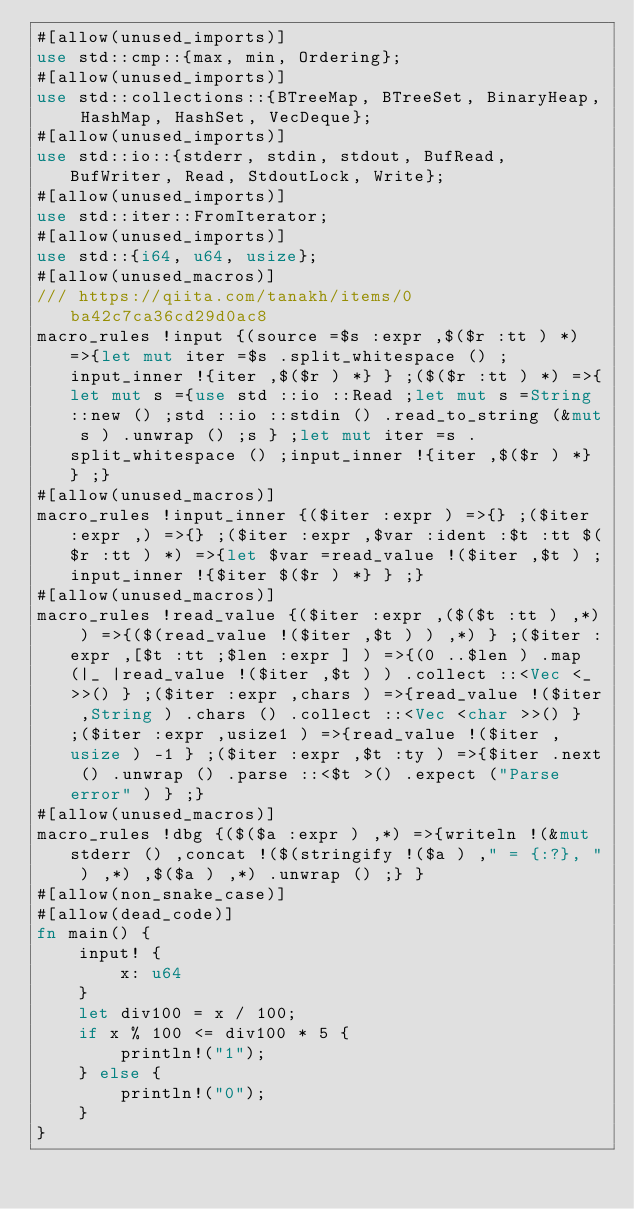Convert code to text. <code><loc_0><loc_0><loc_500><loc_500><_Rust_>#[allow(unused_imports)]
use std::cmp::{max, min, Ordering};
#[allow(unused_imports)]
use std::collections::{BTreeMap, BTreeSet, BinaryHeap, HashMap, HashSet, VecDeque};
#[allow(unused_imports)]
use std::io::{stderr, stdin, stdout, BufRead, BufWriter, Read, StdoutLock, Write};
#[allow(unused_imports)]
use std::iter::FromIterator;
#[allow(unused_imports)]
use std::{i64, u64, usize};
#[allow(unused_macros)]
/// https://qiita.com/tanakh/items/0ba42c7ca36cd29d0ac8
macro_rules !input {(source =$s :expr ,$($r :tt ) *) =>{let mut iter =$s .split_whitespace () ;input_inner !{iter ,$($r ) *} } ;($($r :tt ) *) =>{let mut s ={use std ::io ::Read ;let mut s =String ::new () ;std ::io ::stdin () .read_to_string (&mut s ) .unwrap () ;s } ;let mut iter =s .split_whitespace () ;input_inner !{iter ,$($r ) *} } ;}
#[allow(unused_macros)]
macro_rules !input_inner {($iter :expr ) =>{} ;($iter :expr ,) =>{} ;($iter :expr ,$var :ident :$t :tt $($r :tt ) *) =>{let $var =read_value !($iter ,$t ) ;input_inner !{$iter $($r ) *} } ;}
#[allow(unused_macros)]
macro_rules !read_value {($iter :expr ,($($t :tt ) ,*) ) =>{($(read_value !($iter ,$t ) ) ,*) } ;($iter :expr ,[$t :tt ;$len :expr ] ) =>{(0 ..$len ) .map (|_ |read_value !($iter ,$t ) ) .collect ::<Vec <_ >>() } ;($iter :expr ,chars ) =>{read_value !($iter ,String ) .chars () .collect ::<Vec <char >>() } ;($iter :expr ,usize1 ) =>{read_value !($iter ,usize ) -1 } ;($iter :expr ,$t :ty ) =>{$iter .next () .unwrap () .parse ::<$t >() .expect ("Parse error" ) } ;}
#[allow(unused_macros)]
macro_rules !dbg {($($a :expr ) ,*) =>{writeln !(&mut stderr () ,concat !($(stringify !($a ) ," = {:?}, " ) ,*) ,$($a ) ,*) .unwrap () ;} }
#[allow(non_snake_case)]
#[allow(dead_code)]
fn main() {
    input! {
        x: u64
    }
    let div100 = x / 100;
    if x % 100 <= div100 * 5 {
        println!("1");
    } else {
        println!("0");
    }
}</code> 